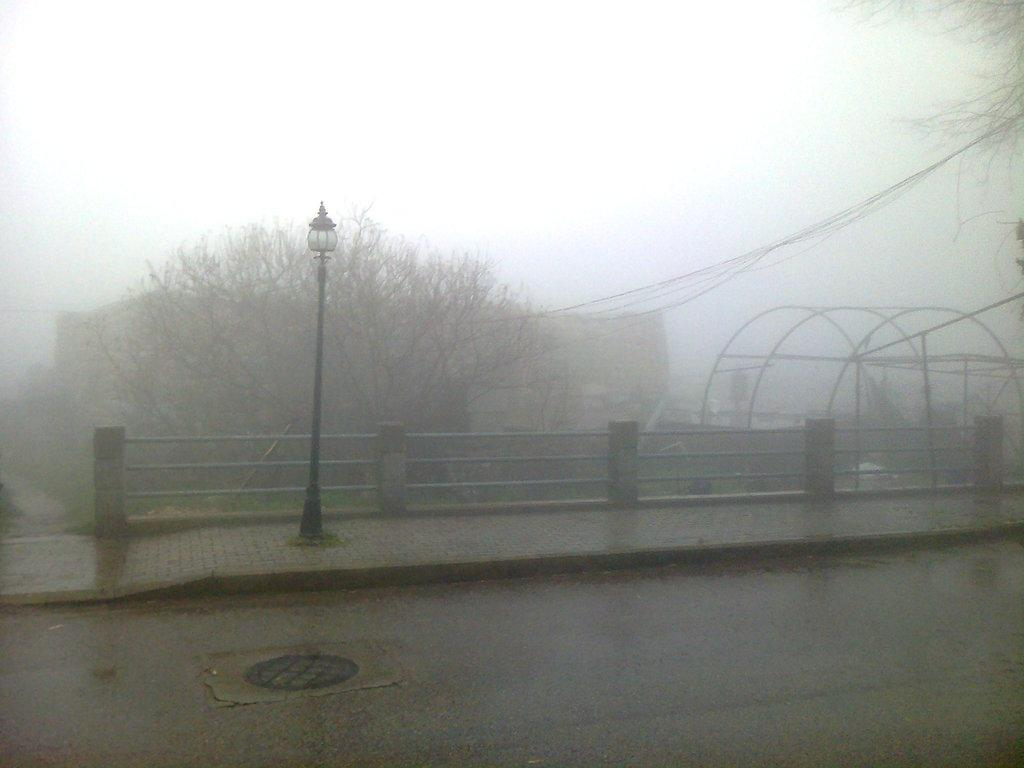What is located in the center of the image? There is a railing in the center of the image. What can be seen at the bottom of the image? There is a road at the bottom of the image. What type of natural elements are visible in the background of the image? There are trees in the background of the image. What structures can be seen in the background of the image? There is a pole, a light, and wires in the background of the image. What additional object is present in the background of the image? There is a net in the background of the image. What is visible at the top of the image? The sky is visible at the top of the image. What is the name of the invention that the trees are using to communicate in the image? There is no invention or communication between trees depicted in the image. How many toes can be seen on the pole in the background of the image? There are no toes visible in the image, as the pole is an inanimate object. 